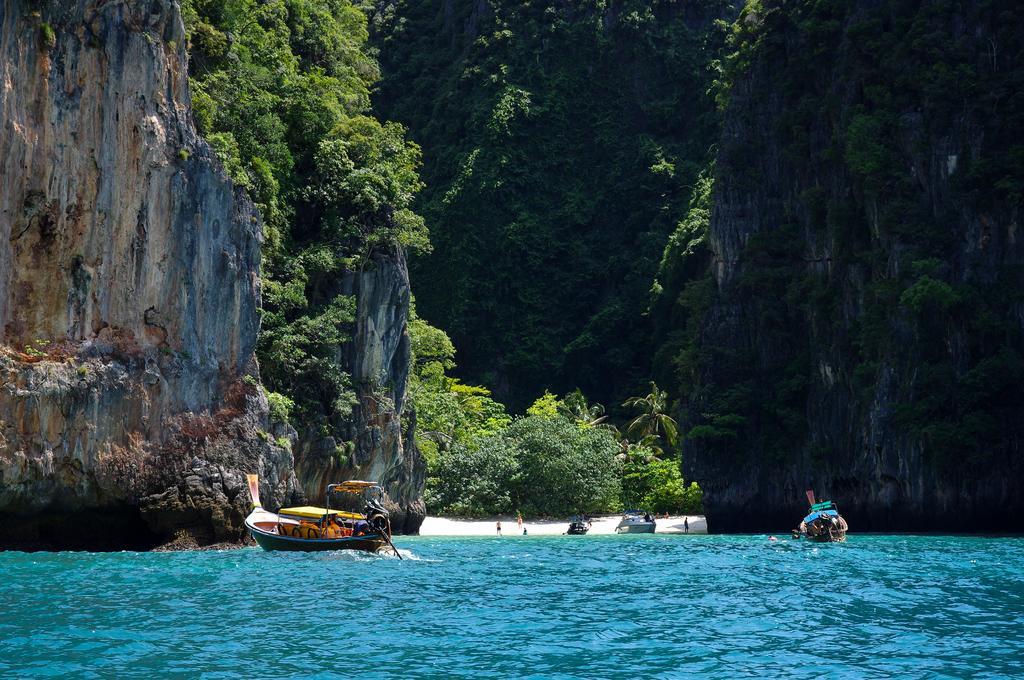How would you summarize this image in a sentence or two? this picture shows hills and trees on them and we see few boats on the water and few trees on the ground looks like a Small Island 